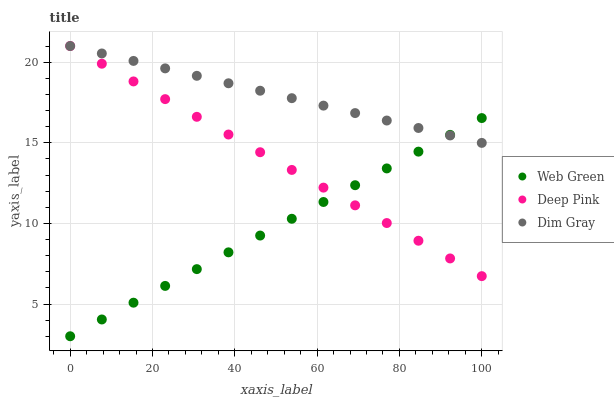Does Web Green have the minimum area under the curve?
Answer yes or no. Yes. Does Dim Gray have the maximum area under the curve?
Answer yes or no. Yes. Does Deep Pink have the minimum area under the curve?
Answer yes or no. No. Does Deep Pink have the maximum area under the curve?
Answer yes or no. No. Is Web Green the smoothest?
Answer yes or no. Yes. Is Dim Gray the roughest?
Answer yes or no. Yes. Is Deep Pink the smoothest?
Answer yes or no. No. Is Deep Pink the roughest?
Answer yes or no. No. Does Web Green have the lowest value?
Answer yes or no. Yes. Does Deep Pink have the lowest value?
Answer yes or no. No. Does Deep Pink have the highest value?
Answer yes or no. Yes. Does Web Green have the highest value?
Answer yes or no. No. Does Web Green intersect Dim Gray?
Answer yes or no. Yes. Is Web Green less than Dim Gray?
Answer yes or no. No. Is Web Green greater than Dim Gray?
Answer yes or no. No. 